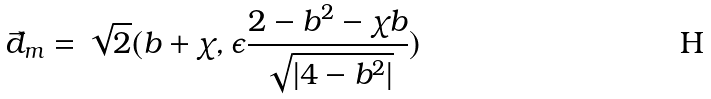Convert formula to latex. <formula><loc_0><loc_0><loc_500><loc_500>\vec { d } _ { m } = \sqrt { 2 } ( b + \chi , \epsilon \frac { 2 - b ^ { 2 } - \chi b } { \sqrt { | 4 - b ^ { 2 } | } } )</formula> 